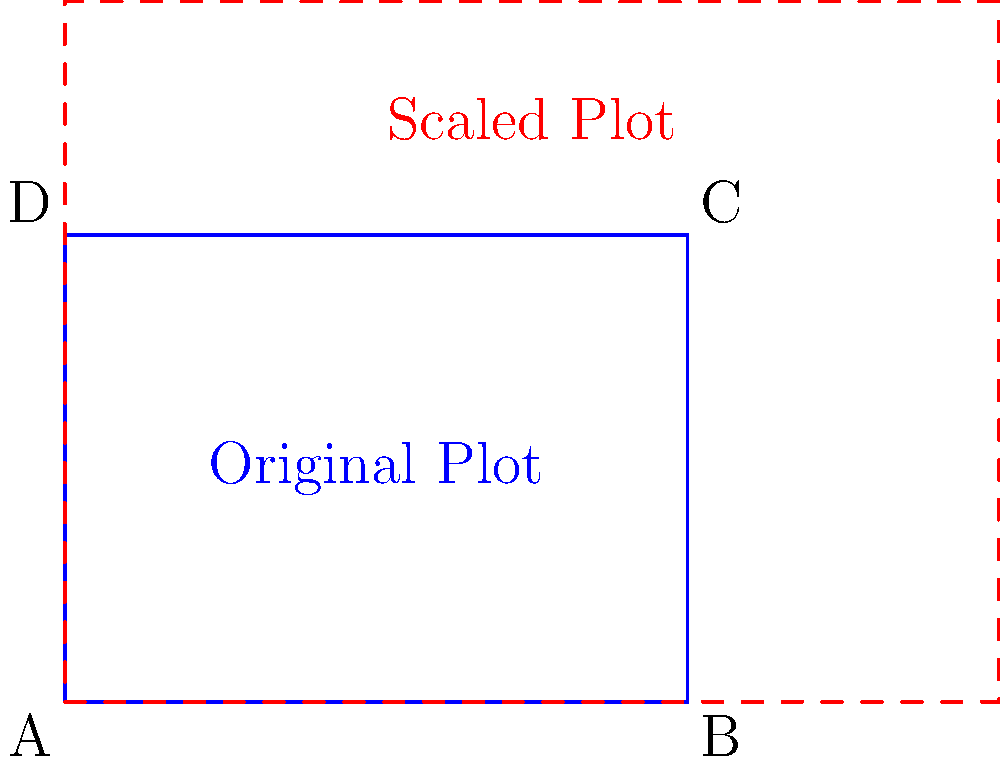A farmer wants to scale up their rectangular farm plot to increase crop yield. The original plot measures 4 units wide and 3 units long. If the farmer wants to increase the area by 125%, what should be the dimensions of the new plot? Assume the plot maintains its rectangular shape and the scaling is uniform in both directions. Let's approach this step-by-step:

1) First, let's calculate the original area:
   Original area = $4 \times 3 = 12$ square units

2) We need to increase this area by 125%, which means multiply it by 2.25:
   New area = $12 \times 2.25 = 27$ square units

3) To maintain the same proportions, we need to scale both dimensions by the same factor. Let's call this factor $x$.

4) If we scale both dimensions by $x$, the new dimensions will be:
   New width = $4x$
   New length = $3x$

5) The new area should equal the product of these new dimensions:
   $27 = 4x \times 3x = 12x^2$

6) Solving for $x$:
   $x^2 = 27 \div 12 = 2.25$
   $x = \sqrt{2.25} = 1.5$

7) Now we can calculate the new dimensions:
   New width = $4 \times 1.5 = 6$ units
   New length = $3 \times 1.5 = 4.5$ units

Therefore, the new plot should measure 6 units wide and 4.5 units long.
Answer: 6 units wide, 4.5 units long 